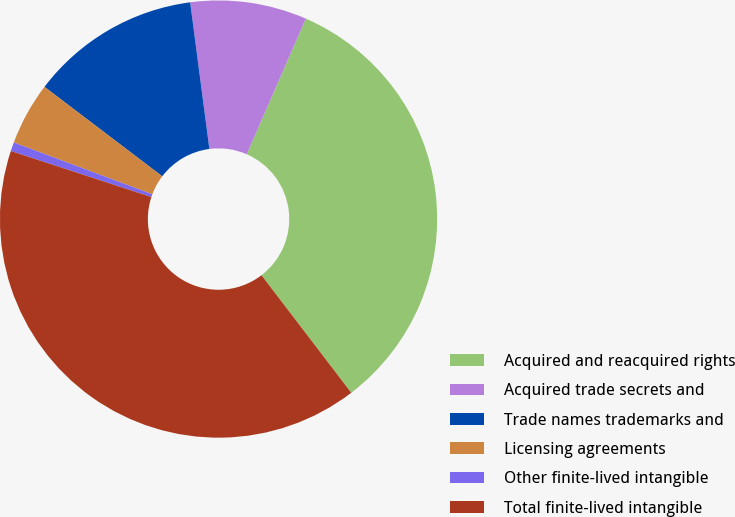Convert chart to OTSL. <chart><loc_0><loc_0><loc_500><loc_500><pie_chart><fcel>Acquired and reacquired rights<fcel>Acquired trade secrets and<fcel>Trade names trademarks and<fcel>Licensing agreements<fcel>Other finite-lived intangible<fcel>Total finite-lived intangible<nl><fcel>33.08%<fcel>8.61%<fcel>12.59%<fcel>4.64%<fcel>0.66%<fcel>40.42%<nl></chart> 